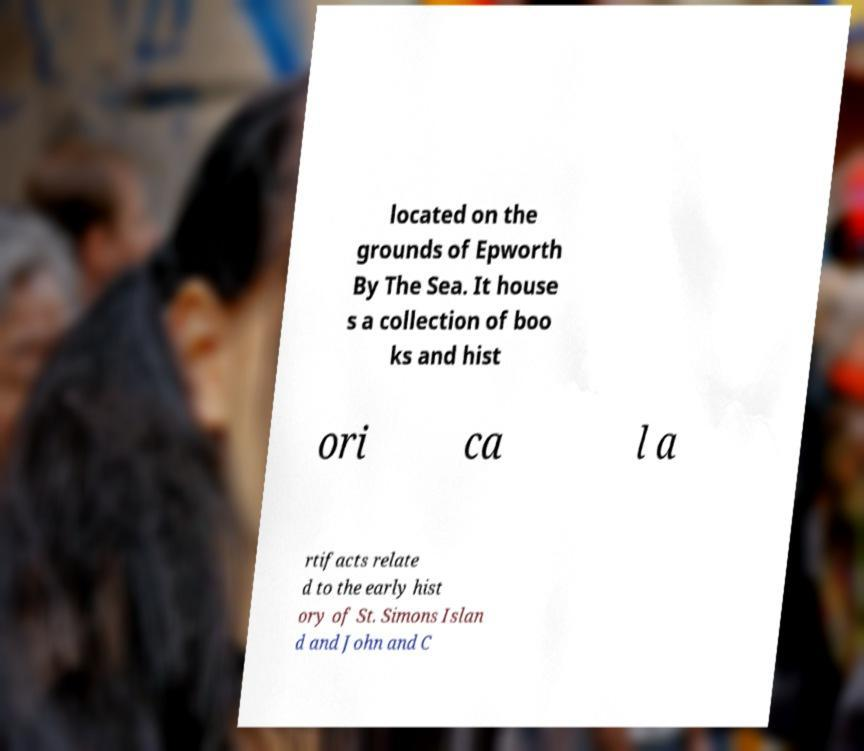There's text embedded in this image that I need extracted. Can you transcribe it verbatim? located on the grounds of Epworth By The Sea. It house s a collection of boo ks and hist ori ca l a rtifacts relate d to the early hist ory of St. Simons Islan d and John and C 